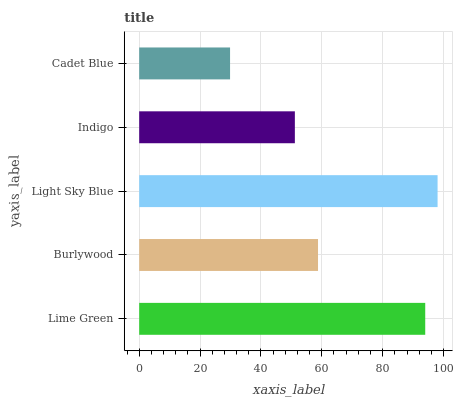Is Cadet Blue the minimum?
Answer yes or no. Yes. Is Light Sky Blue the maximum?
Answer yes or no. Yes. Is Burlywood the minimum?
Answer yes or no. No. Is Burlywood the maximum?
Answer yes or no. No. Is Lime Green greater than Burlywood?
Answer yes or no. Yes. Is Burlywood less than Lime Green?
Answer yes or no. Yes. Is Burlywood greater than Lime Green?
Answer yes or no. No. Is Lime Green less than Burlywood?
Answer yes or no. No. Is Burlywood the high median?
Answer yes or no. Yes. Is Burlywood the low median?
Answer yes or no. Yes. Is Indigo the high median?
Answer yes or no. No. Is Light Sky Blue the low median?
Answer yes or no. No. 